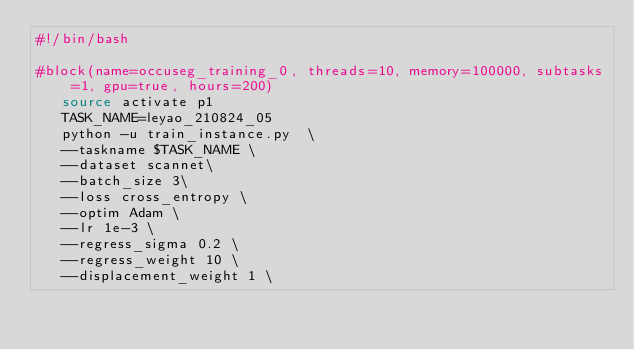Convert code to text. <code><loc_0><loc_0><loc_500><loc_500><_Bash_>#!/bin/bash

#block(name=occuseg_training_0, threads=10, memory=100000, subtasks=1, gpu=true, hours=200)
   source activate p1
   TASK_NAME=leyao_210824_05
   python -u train_instance.py  \
   --taskname $TASK_NAME \
   --dataset scannet\
   --batch_size 3\
   --loss cross_entropy \
   --optim Adam \
   --lr 1e-3 \
   --regress_sigma 0.2 \
   --regress_weight 10 \
   --displacement_weight 1 \</code> 